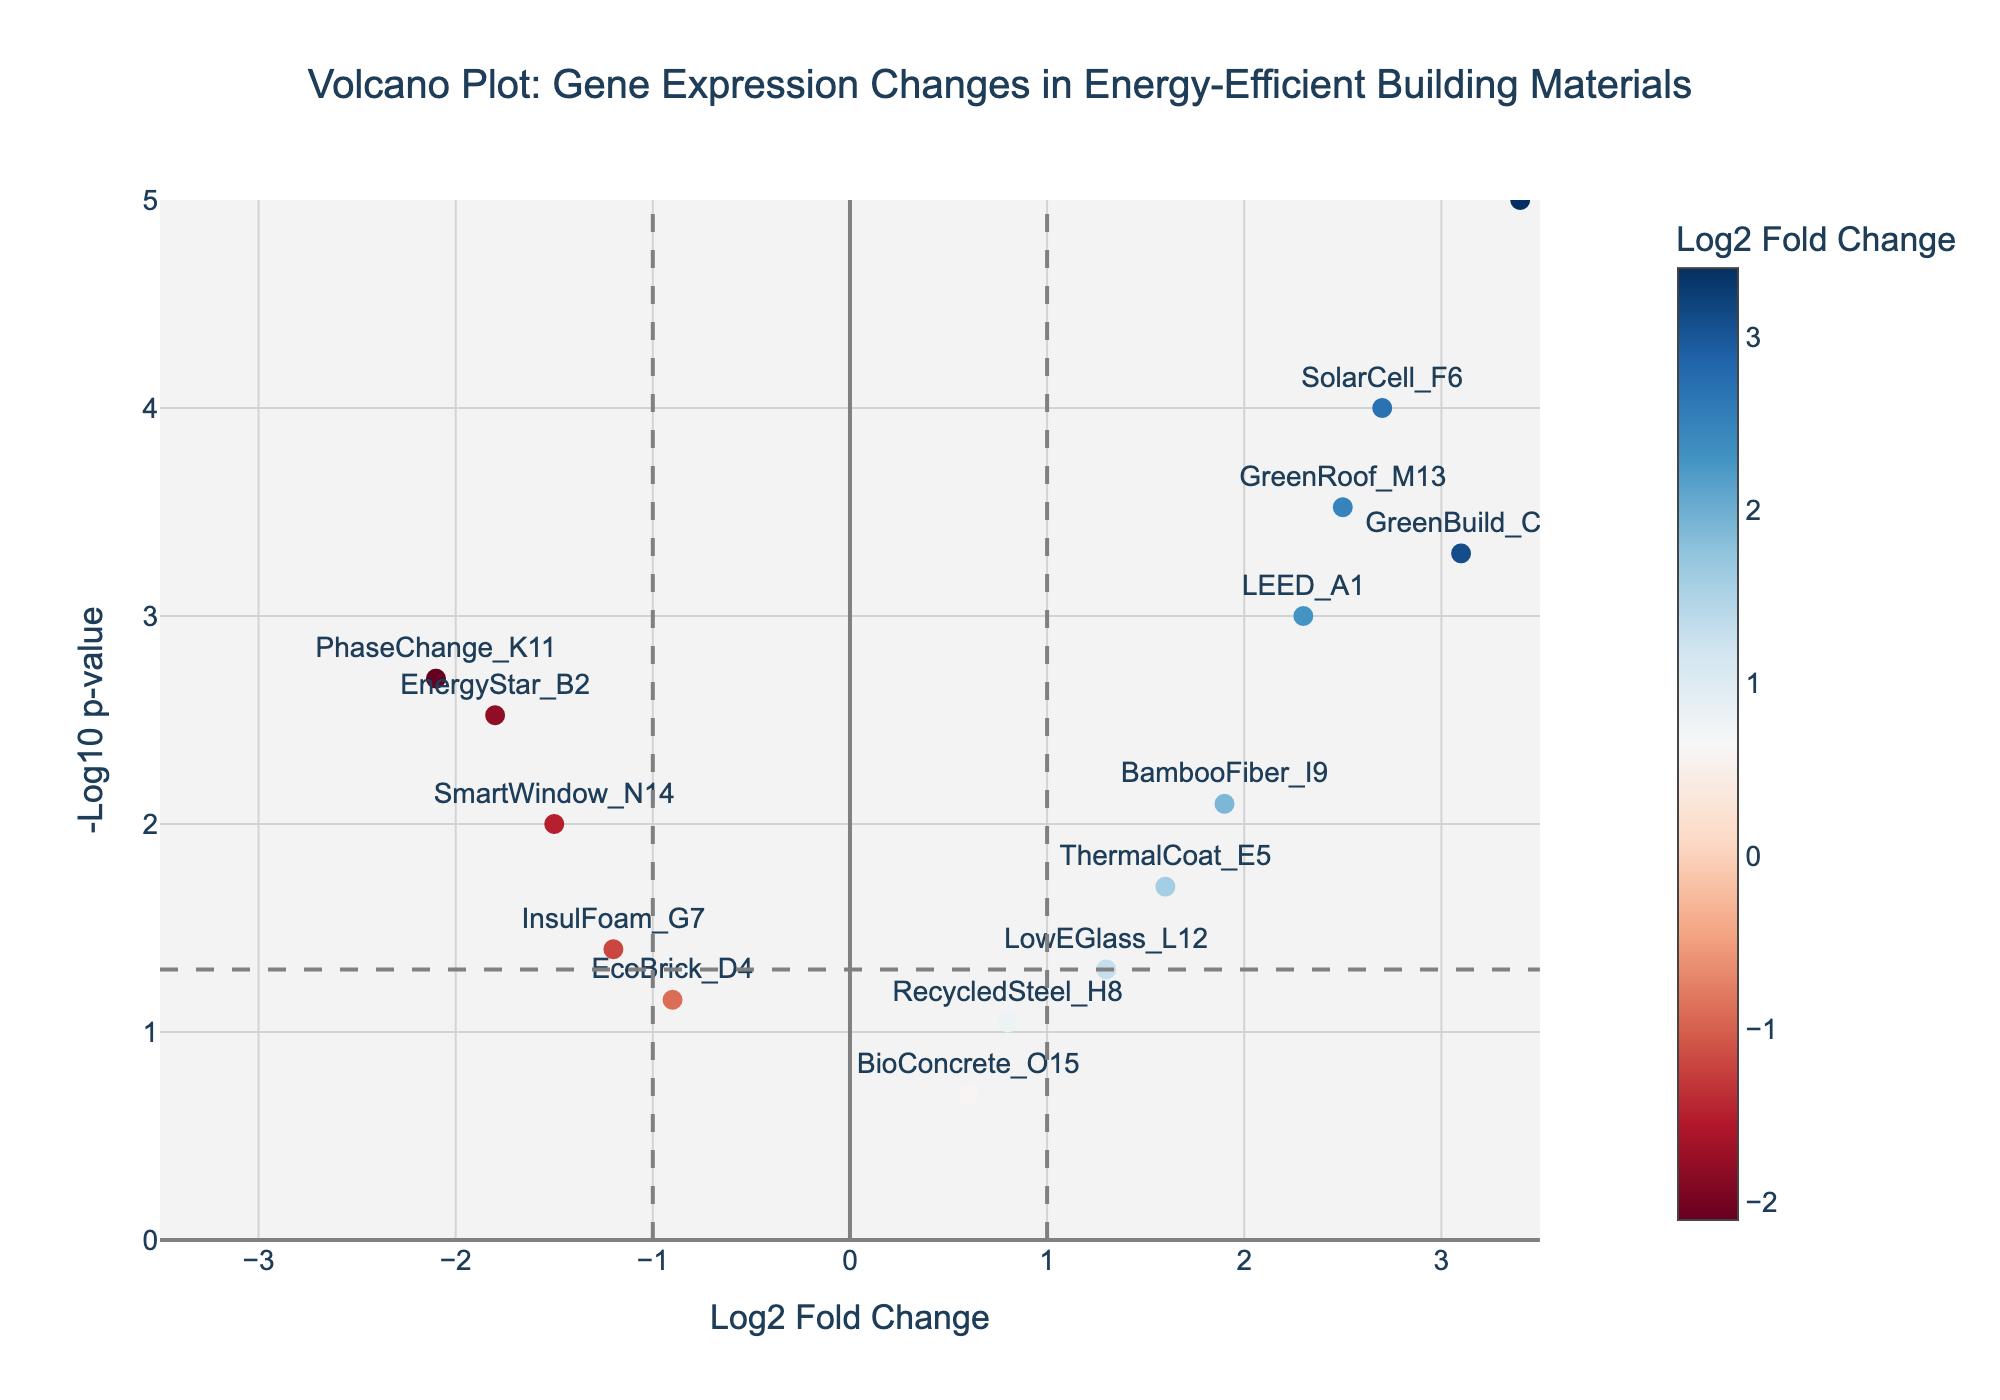What's the title of the plot? The title of the plot is typically located at the top of the figure. In this case, we observe the text "Volcano Plot: Gene Expression Changes in Energy-Efficient Building Materials".
Answer: Volcano Plot: Gene Expression Changes in Energy-Efficient Building Materials What do the x and y axes represent? The labels for the axes are "Log2 Fold Change" for the x-axis and "-Log10 p-value" for the y-axis. These labels indicate what each axis measures.
Answer: Log2 Fold Change (x-axis), -Log10 p-value (y-axis) Which data point has the highest -log10 p-value? By observing the y-axis, we can see that the point with the highest value is the one furthest up. This appears to be AeroGel_J10 with a -log10 p-value of nearly 5.
Answer: AeroGel_J10 How many data points fall within the significant threshold (p-value < 0.05)? The threshold line for p-value significance (p < 0.05) is drawn horizontally on the plot. Data points above this line are considered significant. Counting these points, we find 10 such data points.
Answer: 10 Which gene has the highest log2 fold change and what is its p-value? The data point with the highest log2 fold change is on the far right. According to the data, this is AeroGel_J10 with a log2 fold change of 3.4 and a p-value of 0.00001.
Answer: AeroGel_J10; 0.00001 Compare the log2 fold change of LEED_A1 and GreenBuild_C3. Which one is larger and by how much? LEED_A1 has a log2 fold change of 2.3, and GreenBuild_C3 has a log2 fold change of 3.1. The difference is 3.1 - 2.3 = 0.8.
Answer: GreenBuild_C3; 0.8 What range of log2 fold change values is covered in the plot? By observing the x-axis range, the plot covers log2 fold changes from -3.5 to +3.5.
Answer: -3.5 to 3.5 Identify the color trend for the data points in relation to the log2 fold change values. The data points are colored based on their log2 fold changes, with a color gradient from blue (negative values) to red (positive values). The colorbar indicates this trend.
Answer: Blue to red based on log2 fold change How many genes have a negative log2 fold change and are significant (p-value < 0.05)? By examining the points to the left of the vertical line at -1 and above the p-value threshold line, we identify three genes: EnergyStar_B2, InsulFoam_G7, and SmartWindow_N14.
Answer: 3 